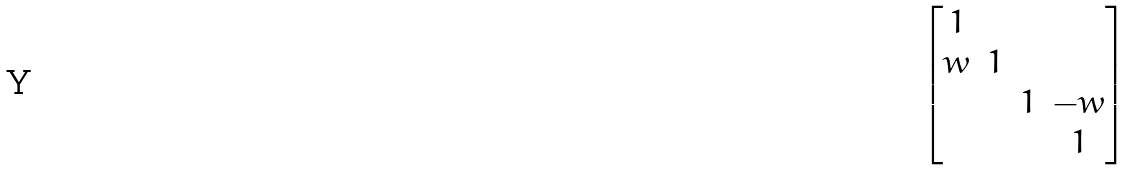<formula> <loc_0><loc_0><loc_500><loc_500>\begin{bmatrix} 1 \\ w & 1 & & \\ & & 1 & - w \\ & & & 1 \end{bmatrix}</formula> 